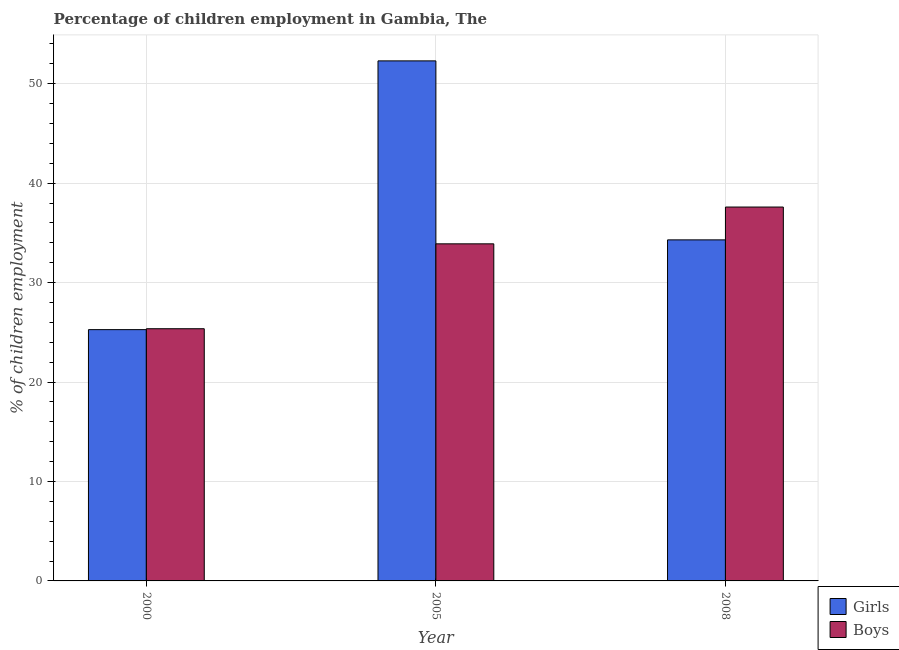How many different coloured bars are there?
Your response must be concise. 2. How many groups of bars are there?
Offer a terse response. 3. How many bars are there on the 2nd tick from the left?
Ensure brevity in your answer.  2. How many bars are there on the 1st tick from the right?
Your answer should be compact. 2. What is the percentage of employed boys in 2008?
Keep it short and to the point. 37.6. Across all years, what is the maximum percentage of employed girls?
Your answer should be compact. 52.3. Across all years, what is the minimum percentage of employed girls?
Keep it short and to the point. 25.27. In which year was the percentage of employed girls minimum?
Your answer should be very brief. 2000. What is the total percentage of employed boys in the graph?
Provide a short and direct response. 96.86. What is the difference between the percentage of employed girls in 2000 and that in 2005?
Your answer should be very brief. -27.03. What is the difference between the percentage of employed girls in 2008 and the percentage of employed boys in 2000?
Offer a terse response. 9.03. What is the average percentage of employed girls per year?
Offer a very short reply. 37.29. In the year 2008, what is the difference between the percentage of employed boys and percentage of employed girls?
Offer a terse response. 0. What is the ratio of the percentage of employed boys in 2000 to that in 2008?
Provide a short and direct response. 0.67. Is the percentage of employed girls in 2000 less than that in 2005?
Your answer should be very brief. Yes. Is the difference between the percentage of employed girls in 2000 and 2005 greater than the difference between the percentage of employed boys in 2000 and 2005?
Offer a terse response. No. What is the difference between the highest and the lowest percentage of employed boys?
Your answer should be compact. 12.24. Is the sum of the percentage of employed girls in 2000 and 2005 greater than the maximum percentage of employed boys across all years?
Offer a very short reply. Yes. What does the 2nd bar from the left in 2008 represents?
Offer a very short reply. Boys. What does the 1st bar from the right in 2005 represents?
Give a very brief answer. Boys. How many bars are there?
Ensure brevity in your answer.  6. What is the difference between two consecutive major ticks on the Y-axis?
Offer a very short reply. 10. Where does the legend appear in the graph?
Give a very brief answer. Bottom right. How many legend labels are there?
Offer a terse response. 2. What is the title of the graph?
Your answer should be very brief. Percentage of children employment in Gambia, The. What is the label or title of the Y-axis?
Make the answer very short. % of children employment. What is the % of children employment of Girls in 2000?
Keep it short and to the point. 25.27. What is the % of children employment in Boys in 2000?
Offer a very short reply. 25.36. What is the % of children employment in Girls in 2005?
Your answer should be very brief. 52.3. What is the % of children employment of Boys in 2005?
Keep it short and to the point. 33.9. What is the % of children employment of Girls in 2008?
Your answer should be very brief. 34.3. What is the % of children employment in Boys in 2008?
Give a very brief answer. 37.6. Across all years, what is the maximum % of children employment in Girls?
Keep it short and to the point. 52.3. Across all years, what is the maximum % of children employment in Boys?
Ensure brevity in your answer.  37.6. Across all years, what is the minimum % of children employment in Girls?
Provide a short and direct response. 25.27. Across all years, what is the minimum % of children employment of Boys?
Provide a succinct answer. 25.36. What is the total % of children employment in Girls in the graph?
Make the answer very short. 111.87. What is the total % of children employment in Boys in the graph?
Offer a very short reply. 96.86. What is the difference between the % of children employment of Girls in 2000 and that in 2005?
Ensure brevity in your answer.  -27.03. What is the difference between the % of children employment of Boys in 2000 and that in 2005?
Ensure brevity in your answer.  -8.54. What is the difference between the % of children employment in Girls in 2000 and that in 2008?
Offer a terse response. -9.03. What is the difference between the % of children employment of Boys in 2000 and that in 2008?
Give a very brief answer. -12.24. What is the difference between the % of children employment of Girls in 2000 and the % of children employment of Boys in 2005?
Provide a short and direct response. -8.63. What is the difference between the % of children employment in Girls in 2000 and the % of children employment in Boys in 2008?
Make the answer very short. -12.33. What is the difference between the % of children employment of Girls in 2005 and the % of children employment of Boys in 2008?
Provide a succinct answer. 14.7. What is the average % of children employment of Girls per year?
Offer a terse response. 37.29. What is the average % of children employment of Boys per year?
Ensure brevity in your answer.  32.29. In the year 2000, what is the difference between the % of children employment in Girls and % of children employment in Boys?
Offer a very short reply. -0.09. In the year 2005, what is the difference between the % of children employment in Girls and % of children employment in Boys?
Offer a terse response. 18.4. In the year 2008, what is the difference between the % of children employment of Girls and % of children employment of Boys?
Offer a terse response. -3.3. What is the ratio of the % of children employment of Girls in 2000 to that in 2005?
Keep it short and to the point. 0.48. What is the ratio of the % of children employment in Boys in 2000 to that in 2005?
Keep it short and to the point. 0.75. What is the ratio of the % of children employment in Girls in 2000 to that in 2008?
Make the answer very short. 0.74. What is the ratio of the % of children employment of Boys in 2000 to that in 2008?
Provide a succinct answer. 0.67. What is the ratio of the % of children employment of Girls in 2005 to that in 2008?
Make the answer very short. 1.52. What is the ratio of the % of children employment in Boys in 2005 to that in 2008?
Offer a very short reply. 0.9. What is the difference between the highest and the lowest % of children employment of Girls?
Offer a very short reply. 27.03. What is the difference between the highest and the lowest % of children employment in Boys?
Provide a short and direct response. 12.24. 